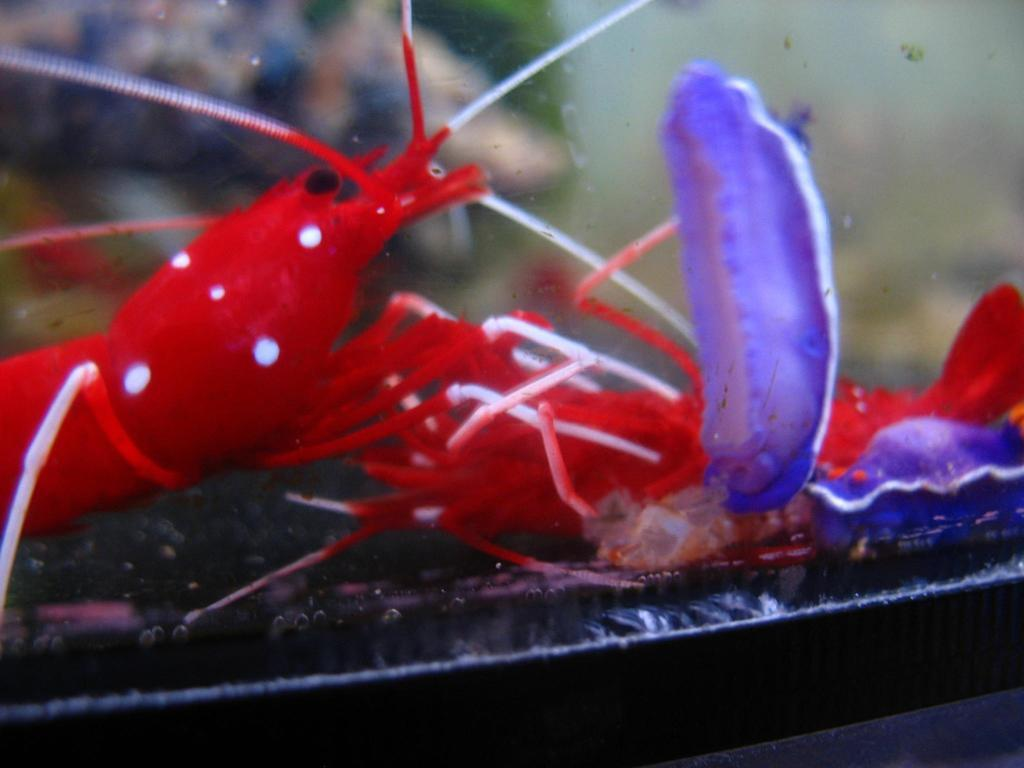What type of seafood can be seen in the image? There are lobsters in the image. What separates the lobsters from the viewer in the image? The lobsters are behind a glass. What colors are the lobsters in the image? The lobsters are in red and white colors. What other color is present in the image besides red and white? There are violet-colored things in the image. What type of leather can be seen on the ant in the image? There are no ants or leather present in the image; it features lobsters behind a glass. What type of bun is being used to hold the lobsters in the image? There are no buns present in the image; the lobsters are behind a glass. 